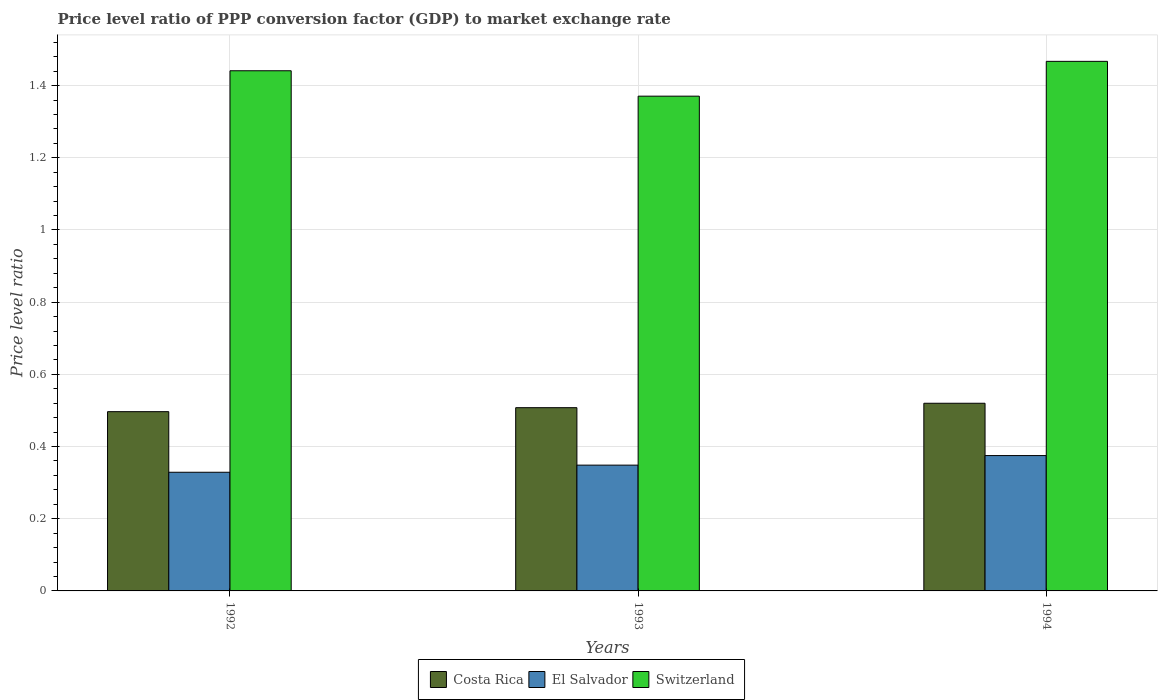Are the number of bars on each tick of the X-axis equal?
Offer a very short reply. Yes. How many bars are there on the 3rd tick from the left?
Offer a terse response. 3. What is the price level ratio in Switzerland in 1994?
Offer a terse response. 1.47. Across all years, what is the maximum price level ratio in Costa Rica?
Your response must be concise. 0.52. Across all years, what is the minimum price level ratio in Costa Rica?
Make the answer very short. 0.5. In which year was the price level ratio in El Salvador maximum?
Offer a very short reply. 1994. In which year was the price level ratio in Switzerland minimum?
Your answer should be very brief. 1993. What is the total price level ratio in El Salvador in the graph?
Offer a terse response. 1.05. What is the difference between the price level ratio in Costa Rica in 1993 and that in 1994?
Your answer should be very brief. -0.01. What is the difference between the price level ratio in Switzerland in 1992 and the price level ratio in Costa Rica in 1994?
Offer a very short reply. 0.92. What is the average price level ratio in Costa Rica per year?
Give a very brief answer. 0.51. In the year 1994, what is the difference between the price level ratio in Costa Rica and price level ratio in El Salvador?
Provide a short and direct response. 0.14. In how many years, is the price level ratio in Costa Rica greater than 1.2400000000000002?
Offer a terse response. 0. What is the ratio of the price level ratio in Costa Rica in 1992 to that in 1993?
Provide a succinct answer. 0.98. Is the price level ratio in El Salvador in 1993 less than that in 1994?
Your answer should be very brief. Yes. What is the difference between the highest and the second highest price level ratio in Costa Rica?
Your answer should be compact. 0.01. What is the difference between the highest and the lowest price level ratio in Switzerland?
Your response must be concise. 0.1. In how many years, is the price level ratio in Costa Rica greater than the average price level ratio in Costa Rica taken over all years?
Offer a very short reply. 1. What does the 1st bar from the left in 1992 represents?
Make the answer very short. Costa Rica. What does the 1st bar from the right in 1994 represents?
Ensure brevity in your answer.  Switzerland. How many years are there in the graph?
Your answer should be very brief. 3. What is the difference between two consecutive major ticks on the Y-axis?
Your answer should be very brief. 0.2. Does the graph contain grids?
Keep it short and to the point. Yes. Where does the legend appear in the graph?
Keep it short and to the point. Bottom center. How many legend labels are there?
Your answer should be compact. 3. What is the title of the graph?
Offer a very short reply. Price level ratio of PPP conversion factor (GDP) to market exchange rate. What is the label or title of the Y-axis?
Keep it short and to the point. Price level ratio. What is the Price level ratio of Costa Rica in 1992?
Your answer should be very brief. 0.5. What is the Price level ratio of El Salvador in 1992?
Make the answer very short. 0.33. What is the Price level ratio in Switzerland in 1992?
Offer a very short reply. 1.44. What is the Price level ratio in Costa Rica in 1993?
Provide a succinct answer. 0.51. What is the Price level ratio of El Salvador in 1993?
Your answer should be very brief. 0.35. What is the Price level ratio of Switzerland in 1993?
Keep it short and to the point. 1.37. What is the Price level ratio in Costa Rica in 1994?
Keep it short and to the point. 0.52. What is the Price level ratio in El Salvador in 1994?
Offer a very short reply. 0.37. What is the Price level ratio in Switzerland in 1994?
Offer a terse response. 1.47. Across all years, what is the maximum Price level ratio of Costa Rica?
Your response must be concise. 0.52. Across all years, what is the maximum Price level ratio of El Salvador?
Provide a short and direct response. 0.37. Across all years, what is the maximum Price level ratio in Switzerland?
Provide a succinct answer. 1.47. Across all years, what is the minimum Price level ratio in Costa Rica?
Your answer should be very brief. 0.5. Across all years, what is the minimum Price level ratio of El Salvador?
Ensure brevity in your answer.  0.33. Across all years, what is the minimum Price level ratio of Switzerland?
Provide a succinct answer. 1.37. What is the total Price level ratio in Costa Rica in the graph?
Offer a very short reply. 1.52. What is the total Price level ratio of El Salvador in the graph?
Ensure brevity in your answer.  1.05. What is the total Price level ratio of Switzerland in the graph?
Your answer should be compact. 4.28. What is the difference between the Price level ratio of Costa Rica in 1992 and that in 1993?
Keep it short and to the point. -0.01. What is the difference between the Price level ratio in El Salvador in 1992 and that in 1993?
Your response must be concise. -0.02. What is the difference between the Price level ratio of Switzerland in 1992 and that in 1993?
Your answer should be very brief. 0.07. What is the difference between the Price level ratio of Costa Rica in 1992 and that in 1994?
Give a very brief answer. -0.02. What is the difference between the Price level ratio in El Salvador in 1992 and that in 1994?
Offer a terse response. -0.05. What is the difference between the Price level ratio in Switzerland in 1992 and that in 1994?
Offer a very short reply. -0.03. What is the difference between the Price level ratio in Costa Rica in 1993 and that in 1994?
Your answer should be very brief. -0.01. What is the difference between the Price level ratio of El Salvador in 1993 and that in 1994?
Your answer should be compact. -0.03. What is the difference between the Price level ratio of Switzerland in 1993 and that in 1994?
Keep it short and to the point. -0.1. What is the difference between the Price level ratio in Costa Rica in 1992 and the Price level ratio in El Salvador in 1993?
Give a very brief answer. 0.15. What is the difference between the Price level ratio of Costa Rica in 1992 and the Price level ratio of Switzerland in 1993?
Your answer should be very brief. -0.87. What is the difference between the Price level ratio of El Salvador in 1992 and the Price level ratio of Switzerland in 1993?
Make the answer very short. -1.04. What is the difference between the Price level ratio of Costa Rica in 1992 and the Price level ratio of El Salvador in 1994?
Offer a very short reply. 0.12. What is the difference between the Price level ratio of Costa Rica in 1992 and the Price level ratio of Switzerland in 1994?
Your response must be concise. -0.97. What is the difference between the Price level ratio in El Salvador in 1992 and the Price level ratio in Switzerland in 1994?
Your answer should be compact. -1.14. What is the difference between the Price level ratio in Costa Rica in 1993 and the Price level ratio in El Salvador in 1994?
Give a very brief answer. 0.13. What is the difference between the Price level ratio of Costa Rica in 1993 and the Price level ratio of Switzerland in 1994?
Your answer should be compact. -0.96. What is the difference between the Price level ratio in El Salvador in 1993 and the Price level ratio in Switzerland in 1994?
Your response must be concise. -1.12. What is the average Price level ratio in Costa Rica per year?
Your response must be concise. 0.51. What is the average Price level ratio in El Salvador per year?
Provide a short and direct response. 0.35. What is the average Price level ratio of Switzerland per year?
Your answer should be very brief. 1.43. In the year 1992, what is the difference between the Price level ratio of Costa Rica and Price level ratio of El Salvador?
Your response must be concise. 0.17. In the year 1992, what is the difference between the Price level ratio in Costa Rica and Price level ratio in Switzerland?
Ensure brevity in your answer.  -0.94. In the year 1992, what is the difference between the Price level ratio of El Salvador and Price level ratio of Switzerland?
Your answer should be very brief. -1.11. In the year 1993, what is the difference between the Price level ratio in Costa Rica and Price level ratio in El Salvador?
Your answer should be compact. 0.16. In the year 1993, what is the difference between the Price level ratio of Costa Rica and Price level ratio of Switzerland?
Provide a short and direct response. -0.86. In the year 1993, what is the difference between the Price level ratio of El Salvador and Price level ratio of Switzerland?
Give a very brief answer. -1.02. In the year 1994, what is the difference between the Price level ratio in Costa Rica and Price level ratio in El Salvador?
Offer a terse response. 0.14. In the year 1994, what is the difference between the Price level ratio of Costa Rica and Price level ratio of Switzerland?
Ensure brevity in your answer.  -0.95. In the year 1994, what is the difference between the Price level ratio in El Salvador and Price level ratio in Switzerland?
Provide a short and direct response. -1.09. What is the ratio of the Price level ratio of Costa Rica in 1992 to that in 1993?
Ensure brevity in your answer.  0.98. What is the ratio of the Price level ratio of El Salvador in 1992 to that in 1993?
Your answer should be very brief. 0.94. What is the ratio of the Price level ratio in Switzerland in 1992 to that in 1993?
Keep it short and to the point. 1.05. What is the ratio of the Price level ratio in Costa Rica in 1992 to that in 1994?
Offer a terse response. 0.96. What is the ratio of the Price level ratio of El Salvador in 1992 to that in 1994?
Your answer should be very brief. 0.88. What is the ratio of the Price level ratio in Switzerland in 1992 to that in 1994?
Offer a terse response. 0.98. What is the ratio of the Price level ratio of Costa Rica in 1993 to that in 1994?
Offer a very short reply. 0.98. What is the ratio of the Price level ratio of El Salvador in 1993 to that in 1994?
Ensure brevity in your answer.  0.93. What is the ratio of the Price level ratio of Switzerland in 1993 to that in 1994?
Offer a very short reply. 0.93. What is the difference between the highest and the second highest Price level ratio of Costa Rica?
Give a very brief answer. 0.01. What is the difference between the highest and the second highest Price level ratio in El Salvador?
Keep it short and to the point. 0.03. What is the difference between the highest and the second highest Price level ratio of Switzerland?
Keep it short and to the point. 0.03. What is the difference between the highest and the lowest Price level ratio of Costa Rica?
Keep it short and to the point. 0.02. What is the difference between the highest and the lowest Price level ratio of El Salvador?
Offer a terse response. 0.05. What is the difference between the highest and the lowest Price level ratio in Switzerland?
Provide a succinct answer. 0.1. 